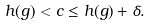Convert formula to latex. <formula><loc_0><loc_0><loc_500><loc_500>h ( g ) < c \leq h ( g ) + \delta .</formula> 